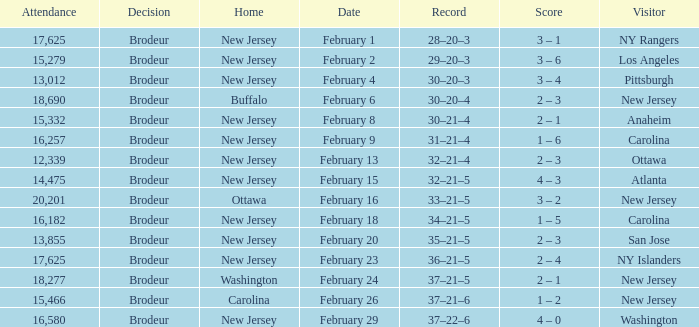What was the record when the visiting team was Ottawa? 32–21–4. 